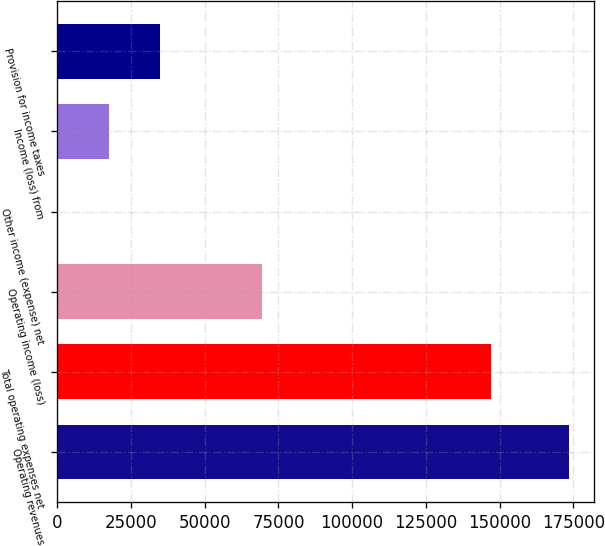Convert chart. <chart><loc_0><loc_0><loc_500><loc_500><bar_chart><fcel>Operating revenues<fcel>Total operating expenses net<fcel>Operating income (loss)<fcel>Other income (expense) net<fcel>Income (loss) from<fcel>Provision for income taxes<nl><fcel>173447<fcel>147012<fcel>69540.8<fcel>270<fcel>17587.7<fcel>34905.4<nl></chart> 